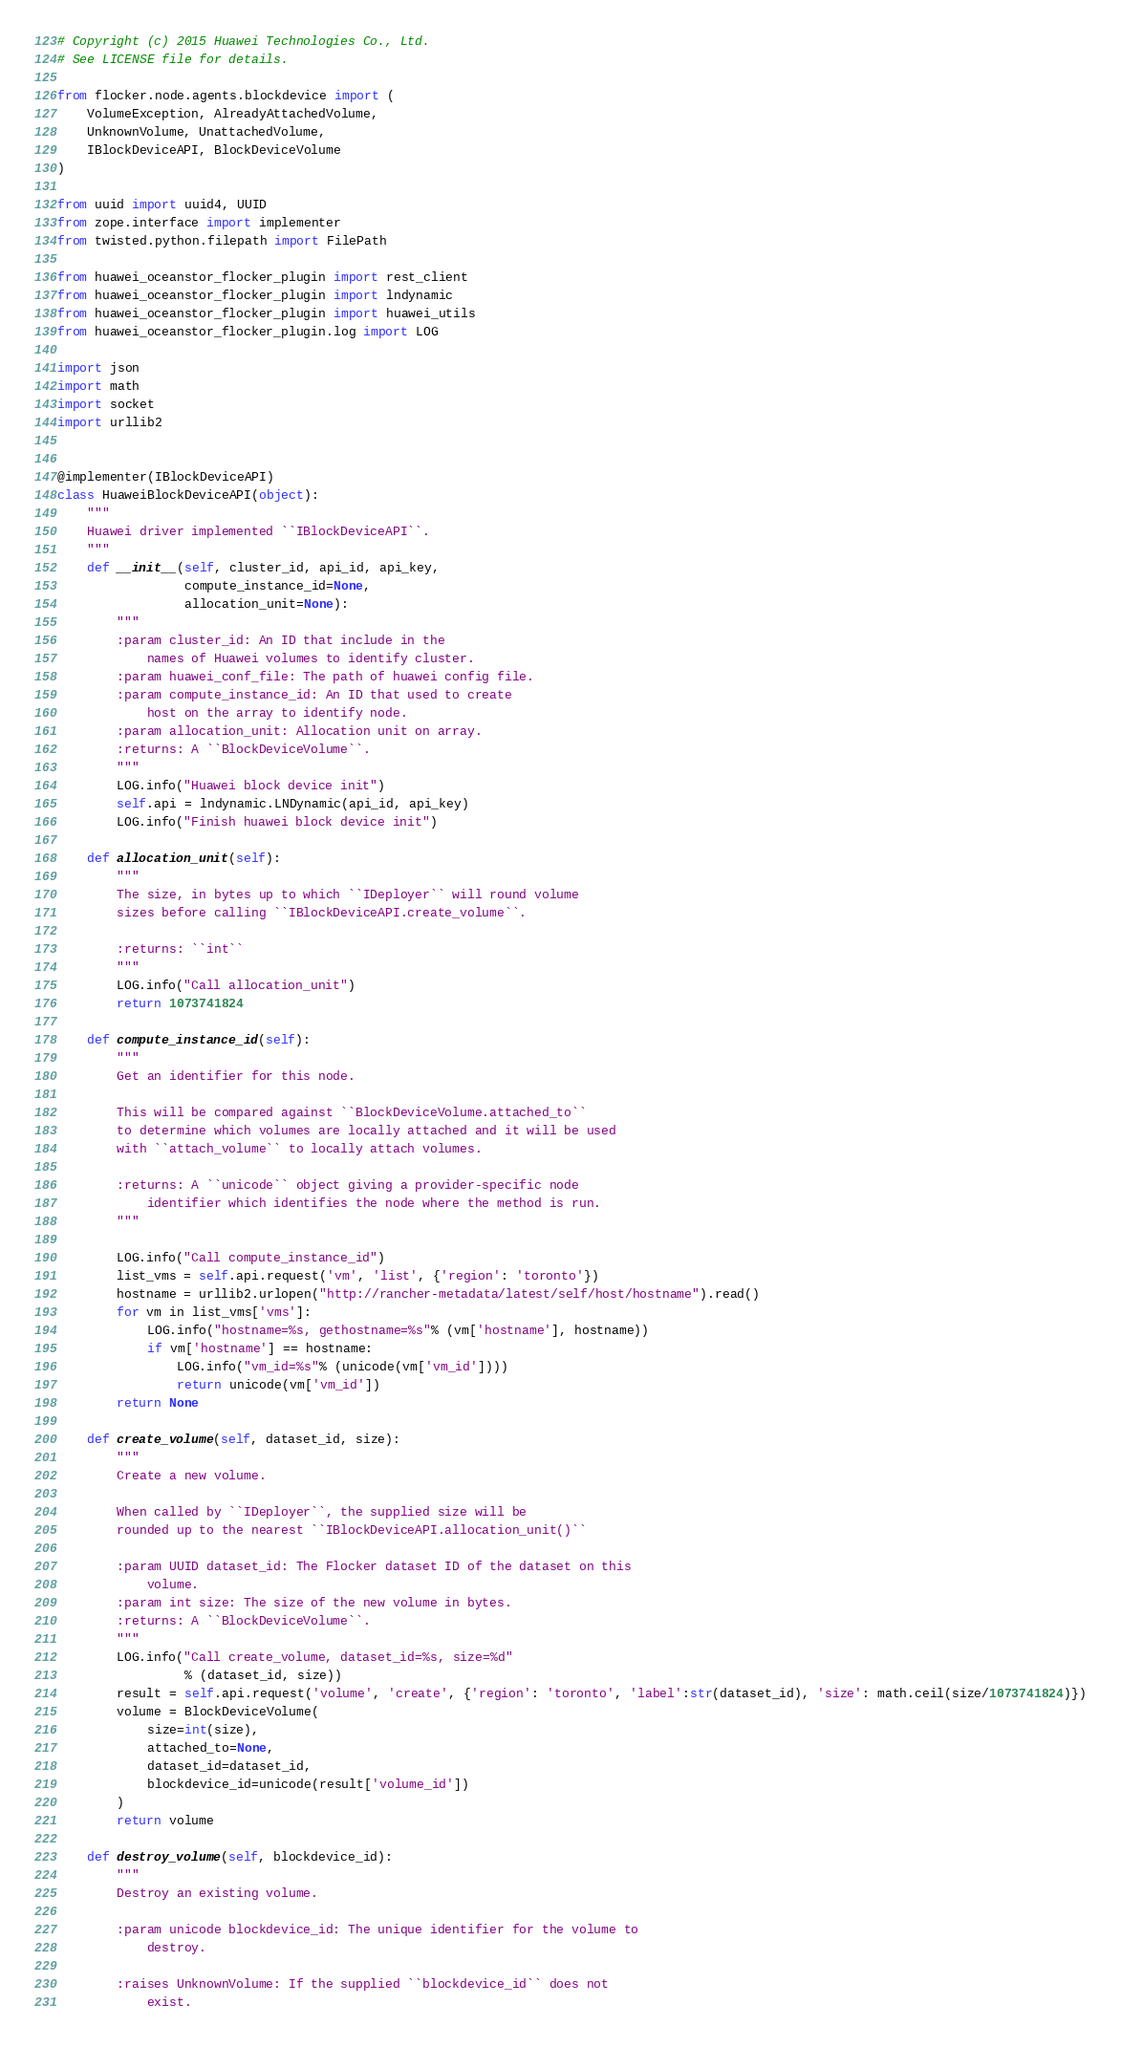Convert code to text. <code><loc_0><loc_0><loc_500><loc_500><_Python_># Copyright (c) 2015 Huawei Technologies Co., Ltd.
# See LICENSE file for details.

from flocker.node.agents.blockdevice import (
    VolumeException, AlreadyAttachedVolume,
    UnknownVolume, UnattachedVolume,
    IBlockDeviceAPI, BlockDeviceVolume
)

from uuid import uuid4, UUID
from zope.interface import implementer
from twisted.python.filepath import FilePath

from huawei_oceanstor_flocker_plugin import rest_client
from huawei_oceanstor_flocker_plugin import lndynamic
from huawei_oceanstor_flocker_plugin import huawei_utils
from huawei_oceanstor_flocker_plugin.log import LOG

import json
import math
import socket
import urllib2


@implementer(IBlockDeviceAPI)
class HuaweiBlockDeviceAPI(object):
    """
    Huawei driver implemented ``IBlockDeviceAPI``.
    """
    def __init__(self, cluster_id, api_id, api_key,
                 compute_instance_id=None,
                 allocation_unit=None):
        """
        :param cluster_id: An ID that include in the
            names of Huawei volumes to identify cluster.
        :param huawei_conf_file: The path of huawei config file.
        :param compute_instance_id: An ID that used to create
            host on the array to identify node.
        :param allocation_unit: Allocation unit on array.
        :returns: A ``BlockDeviceVolume``.
        """
        LOG.info("Huawei block device init")
        self.api = lndynamic.LNDynamic(api_id, api_key)
        LOG.info("Finish huawei block device init")

    def allocation_unit(self):
        """
        The size, in bytes up to which ``IDeployer`` will round volume
        sizes before calling ``IBlockDeviceAPI.create_volume``.

        :returns: ``int``
        """
        LOG.info("Call allocation_unit")
        return 1073741824

    def compute_instance_id(self):
        """
        Get an identifier for this node.

        This will be compared against ``BlockDeviceVolume.attached_to``
        to determine which volumes are locally attached and it will be used
        with ``attach_volume`` to locally attach volumes.

        :returns: A ``unicode`` object giving a provider-specific node
            identifier which identifies the node where the method is run.
        """

        LOG.info("Call compute_instance_id")
        list_vms = self.api.request('vm', 'list', {'region': 'toronto'})
        hostname = urllib2.urlopen("http://rancher-metadata/latest/self/host/hostname").read()
        for vm in list_vms['vms']:
            LOG.info("hostname=%s, gethostname=%s"% (vm['hostname'], hostname))
            if vm['hostname'] == hostname:
                LOG.info("vm_id=%s"% (unicode(vm['vm_id'])))
                return unicode(vm['vm_id'])
        return None

    def create_volume(self, dataset_id, size):
        """
        Create a new volume.

        When called by ``IDeployer``, the supplied size will be
        rounded up to the nearest ``IBlockDeviceAPI.allocation_unit()``

        :param UUID dataset_id: The Flocker dataset ID of the dataset on this
            volume.
        :param int size: The size of the new volume in bytes.
        :returns: A ``BlockDeviceVolume``.
        """
        LOG.info("Call create_volume, dataset_id=%s, size=%d"
                 % (dataset_id, size))
        result = self.api.request('volume', 'create', {'region': 'toronto', 'label':str(dataset_id), 'size': math.ceil(size/1073741824)})
        volume = BlockDeviceVolume(
            size=int(size),
            attached_to=None,
            dataset_id=dataset_id,
            blockdevice_id=unicode(result['volume_id'])
        )
        return volume

    def destroy_volume(self, blockdevice_id):
        """
        Destroy an existing volume.

        :param unicode blockdevice_id: The unique identifier for the volume to
            destroy.

        :raises UnknownVolume: If the supplied ``blockdevice_id`` does not
            exist.
</code> 